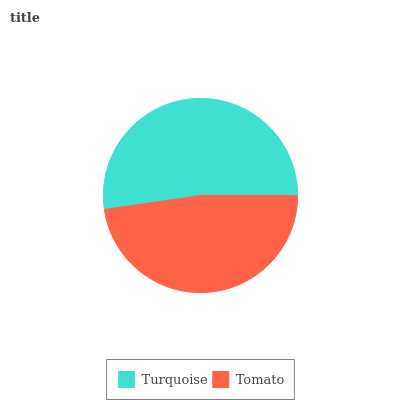Is Tomato the minimum?
Answer yes or no. Yes. Is Turquoise the maximum?
Answer yes or no. Yes. Is Tomato the maximum?
Answer yes or no. No. Is Turquoise greater than Tomato?
Answer yes or no. Yes. Is Tomato less than Turquoise?
Answer yes or no. Yes. Is Tomato greater than Turquoise?
Answer yes or no. No. Is Turquoise less than Tomato?
Answer yes or no. No. Is Turquoise the high median?
Answer yes or no. Yes. Is Tomato the low median?
Answer yes or no. Yes. Is Tomato the high median?
Answer yes or no. No. Is Turquoise the low median?
Answer yes or no. No. 